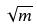<formula> <loc_0><loc_0><loc_500><loc_500>\sqrt { m }</formula> 